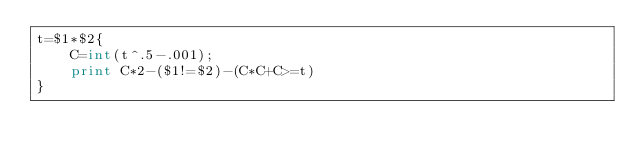<code> <loc_0><loc_0><loc_500><loc_500><_Awk_>t=$1*$2{
	C=int(t^.5-.001);
	print C*2-($1!=$2)-(C*C+C>=t)
}</code> 